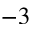<formula> <loc_0><loc_0><loc_500><loc_500>^ { - 3 }</formula> 